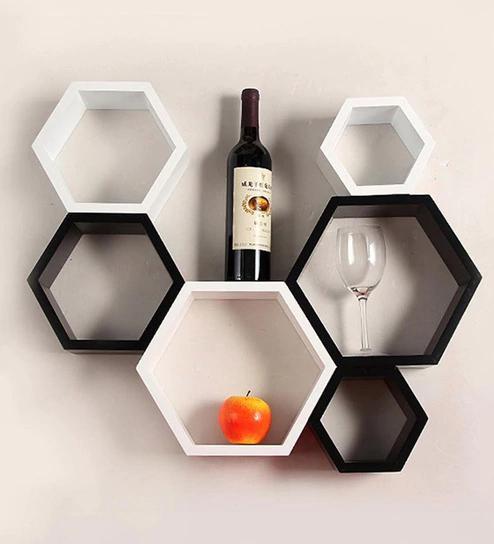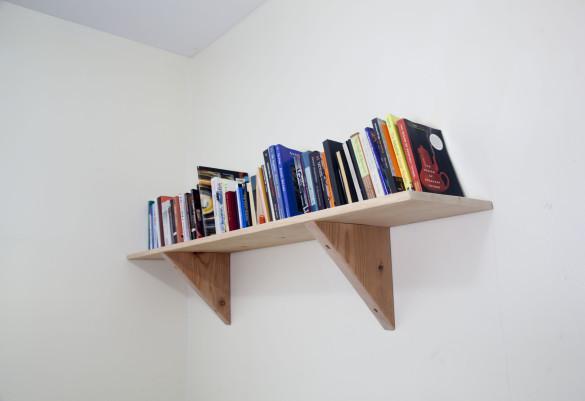The first image is the image on the left, the second image is the image on the right. Analyze the images presented: Is the assertion "Each shelf unit holds some type of items, and one of the units has a single horizontal shelf." valid? Answer yes or no. Yes. The first image is the image on the left, the second image is the image on the right. For the images displayed, is the sentence "The shelf in one of the images is completely black." factually correct? Answer yes or no. No. 